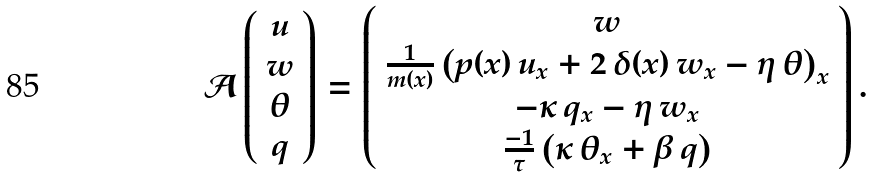Convert formula to latex. <formula><loc_0><loc_0><loc_500><loc_500>\mathcal { A } \left ( \begin{array} { c } u \\ w \\ \theta \\ q \end{array} \right ) = \left ( \begin{array} { c } w \\ \frac { 1 } { m ( x ) } \left ( p ( x ) \, u _ { x } + 2 \, \delta ( x ) \, w _ { x } - \eta \, \theta \right ) _ { x } \\ - \kappa \, q _ { x } - \eta \, w _ { x } \\ \frac { - 1 } { \tau } \left ( \kappa \, \theta _ { x } + \beta \, q \right ) \end{array} \right ) .</formula> 